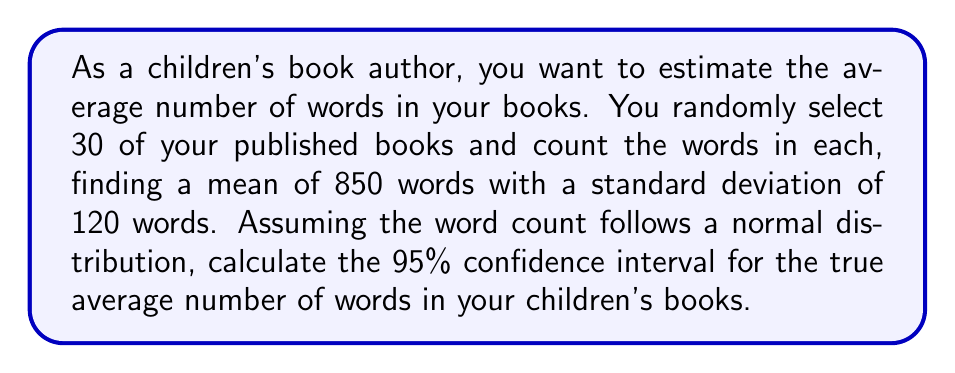Solve this math problem. Let's approach this step-by-step:

1) We're given:
   - Sample size: $n = 30$
   - Sample mean: $\bar{x} = 850$
   - Sample standard deviation: $s = 120$
   - Confidence level: 95% (α = 0.05)

2) For a 95% confidence interval, we use a z-score of 1.96 (from the standard normal distribution table).

3) The formula for the confidence interval is:

   $$\bar{x} \pm z_{\alpha/2} \cdot \frac{s}{\sqrt{n}}$$

4) Substituting our values:

   $$850 \pm 1.96 \cdot \frac{120}{\sqrt{30}}$$

5) Simplify:
   $$850 \pm 1.96 \cdot \frac{120}{5.477}$$
   $$850 \pm 1.96 \cdot 21.91$$
   $$850 \pm 42.94$$

6) Therefore, the confidence interval is:
   $$(850 - 42.94, 850 + 42.94)$$
   $$(807.06, 892.94)$$

7) Rounding to whole numbers (as we're counting words):
   $$(807, 893)$$
Answer: (807, 893) words 